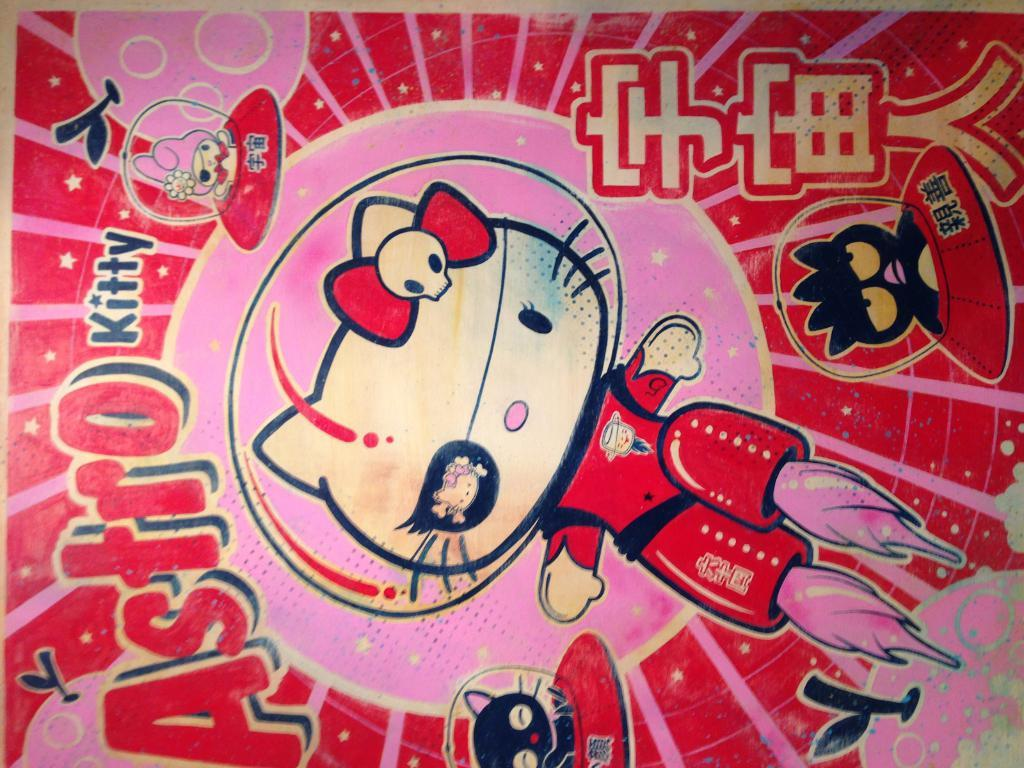What type of animal is depicted in the image? There is a cartoon cat in the image. What is the cat wearing? The cat is wearing a red dress. Are there any other cartoon images in the picture? Yes, there are other cartoon images in the picture. How many men are wearing skirts in the image? There are no men or skirts present in the image, as it features a cartoon cat wearing a red dress and other cartoon images. 